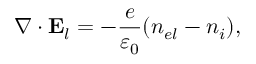Convert formula to latex. <formula><loc_0><loc_0><loc_500><loc_500>\nabla \cdot { E } _ { l } = - \frac { e } { \varepsilon _ { 0 } } ( n _ { e l } - n _ { i } ) ,</formula> 